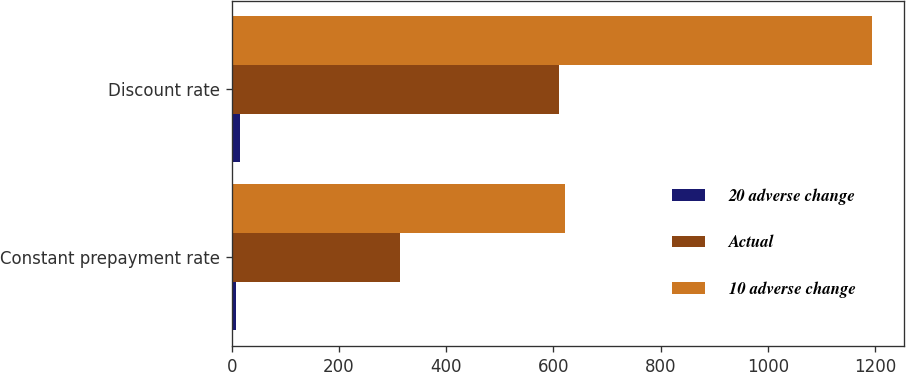<chart> <loc_0><loc_0><loc_500><loc_500><stacked_bar_chart><ecel><fcel>Constant prepayment rate<fcel>Discount rate<nl><fcel>20 adverse change<fcel>7.6<fcel>15<nl><fcel>Actual<fcel>313<fcel>610<nl><fcel>10 adverse change<fcel>622<fcel>1194<nl></chart> 